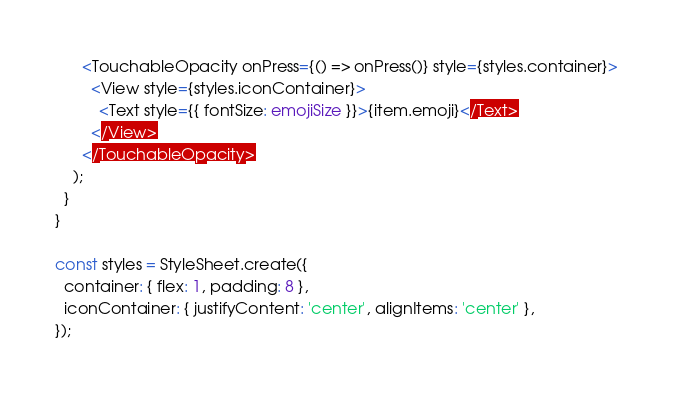<code> <loc_0><loc_0><loc_500><loc_500><_TypeScript_>      <TouchableOpacity onPress={() => onPress()} style={styles.container}>
        <View style={styles.iconContainer}>
          <Text style={{ fontSize: emojiSize }}>{item.emoji}</Text>
        </View>
      </TouchableOpacity>
    );
  }
}

const styles = StyleSheet.create({
  container: { flex: 1, padding: 8 },
  iconContainer: { justifyContent: 'center', alignItems: 'center' },
});
</code> 